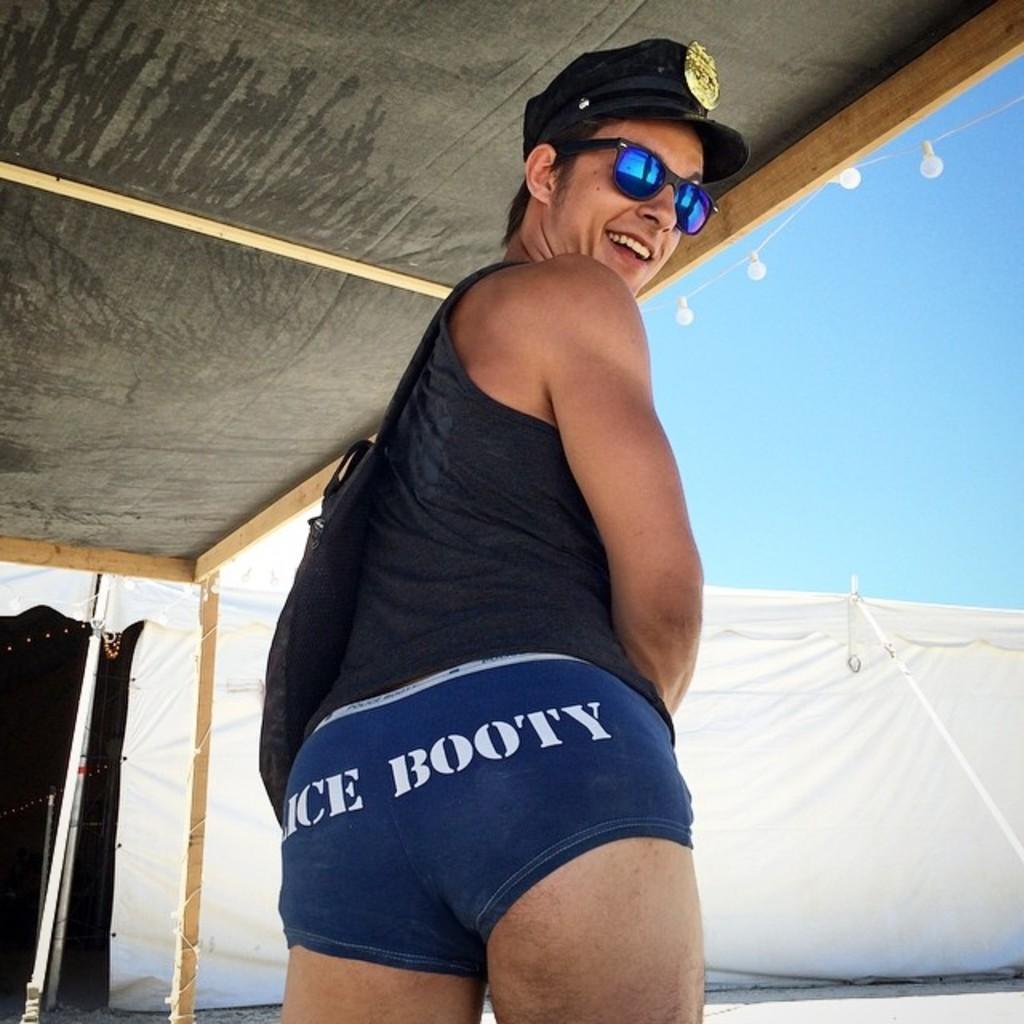Can you describe this image briefly? In this image I can see the person with the dress and the person is under the shed. I can see few lights to the shed. In the background I can see the tent and the sky. 